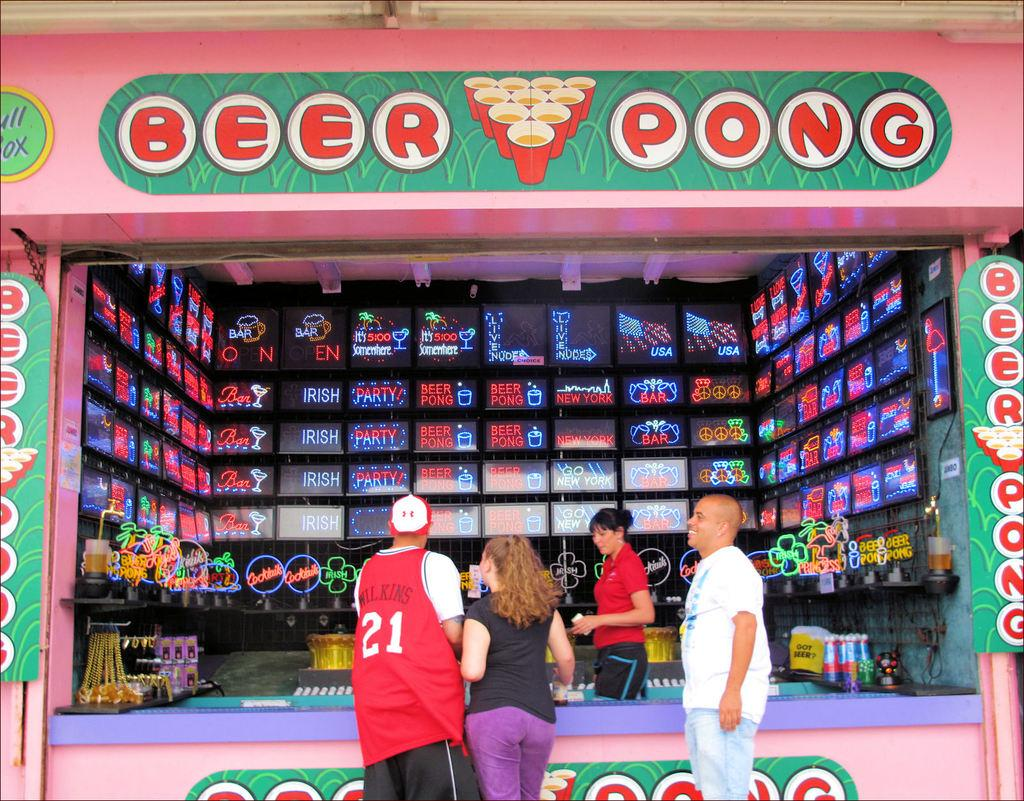<image>
Provide a brief description of the given image. Large booth that two people are standing in front of that reads Beer Pong. 